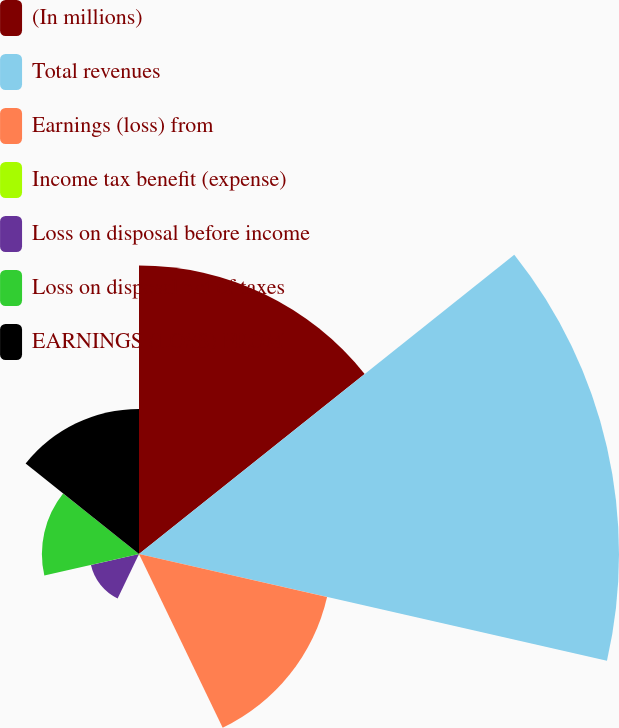Convert chart. <chart><loc_0><loc_0><loc_500><loc_500><pie_chart><fcel>(In millions)<fcel>Total revenues<fcel>Earnings (loss) from<fcel>Income tax benefit (expense)<fcel>Loss on disposal before income<fcel>Loss on disposal net of taxes<fcel>EARNINGS (LOSS) FROM<nl><fcel>23.01%<fcel>38.27%<fcel>15.38%<fcel>0.11%<fcel>3.93%<fcel>7.74%<fcel>11.56%<nl></chart> 